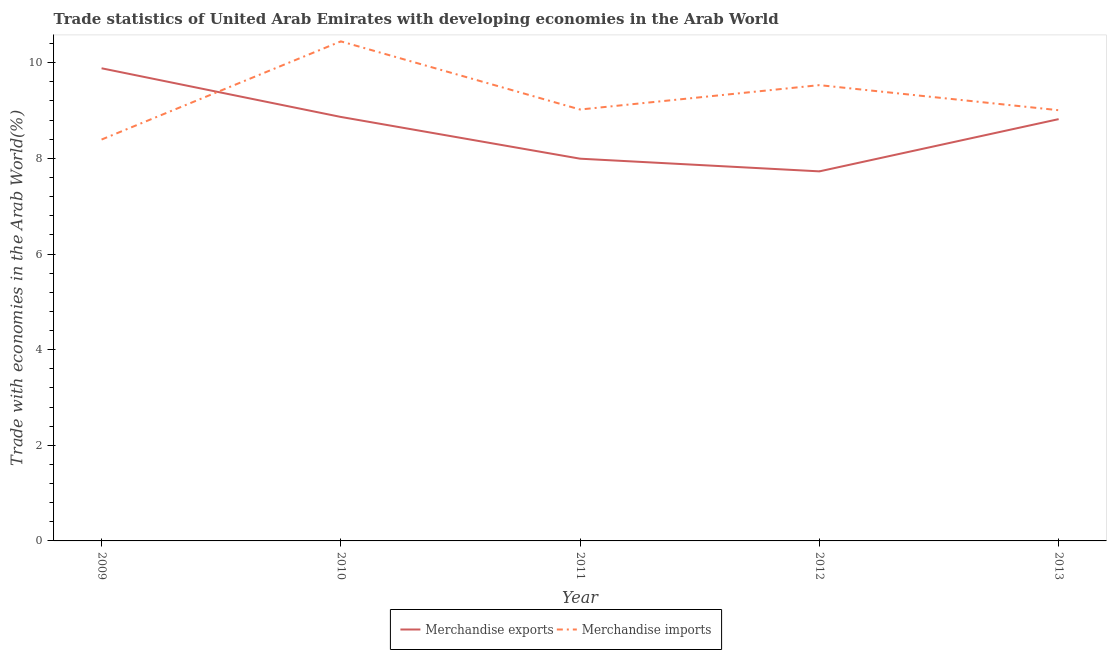Is the number of lines equal to the number of legend labels?
Offer a terse response. Yes. What is the merchandise exports in 2011?
Keep it short and to the point. 7.99. Across all years, what is the maximum merchandise exports?
Your response must be concise. 9.88. Across all years, what is the minimum merchandise exports?
Give a very brief answer. 7.73. What is the total merchandise exports in the graph?
Keep it short and to the point. 43.29. What is the difference between the merchandise imports in 2012 and that in 2013?
Ensure brevity in your answer.  0.52. What is the difference between the merchandise exports in 2010 and the merchandise imports in 2009?
Your response must be concise. 0.47. What is the average merchandise exports per year?
Offer a terse response. 8.66. In the year 2013, what is the difference between the merchandise imports and merchandise exports?
Offer a terse response. 0.19. In how many years, is the merchandise imports greater than 4 %?
Your answer should be very brief. 5. What is the ratio of the merchandise imports in 2010 to that in 2012?
Give a very brief answer. 1.1. What is the difference between the highest and the second highest merchandise exports?
Provide a succinct answer. 1.02. What is the difference between the highest and the lowest merchandise exports?
Give a very brief answer. 2.16. In how many years, is the merchandise exports greater than the average merchandise exports taken over all years?
Give a very brief answer. 3. Is the sum of the merchandise imports in 2010 and 2011 greater than the maximum merchandise exports across all years?
Your answer should be compact. Yes. Is the merchandise imports strictly less than the merchandise exports over the years?
Your answer should be compact. No. How many lines are there?
Give a very brief answer. 2. What is the difference between two consecutive major ticks on the Y-axis?
Provide a short and direct response. 2. Does the graph contain grids?
Offer a very short reply. No. Where does the legend appear in the graph?
Make the answer very short. Bottom center. What is the title of the graph?
Your response must be concise. Trade statistics of United Arab Emirates with developing economies in the Arab World. What is the label or title of the Y-axis?
Make the answer very short. Trade with economies in the Arab World(%). What is the Trade with economies in the Arab World(%) of Merchandise exports in 2009?
Give a very brief answer. 9.88. What is the Trade with economies in the Arab World(%) in Merchandise imports in 2009?
Ensure brevity in your answer.  8.39. What is the Trade with economies in the Arab World(%) of Merchandise exports in 2010?
Offer a terse response. 8.87. What is the Trade with economies in the Arab World(%) in Merchandise imports in 2010?
Offer a very short reply. 10.45. What is the Trade with economies in the Arab World(%) of Merchandise exports in 2011?
Offer a terse response. 7.99. What is the Trade with economies in the Arab World(%) of Merchandise imports in 2011?
Keep it short and to the point. 9.02. What is the Trade with economies in the Arab World(%) of Merchandise exports in 2012?
Your answer should be compact. 7.73. What is the Trade with economies in the Arab World(%) in Merchandise imports in 2012?
Your answer should be very brief. 9.53. What is the Trade with economies in the Arab World(%) in Merchandise exports in 2013?
Offer a very short reply. 8.82. What is the Trade with economies in the Arab World(%) in Merchandise imports in 2013?
Provide a short and direct response. 9.01. Across all years, what is the maximum Trade with economies in the Arab World(%) of Merchandise exports?
Your answer should be very brief. 9.88. Across all years, what is the maximum Trade with economies in the Arab World(%) in Merchandise imports?
Provide a short and direct response. 10.45. Across all years, what is the minimum Trade with economies in the Arab World(%) in Merchandise exports?
Give a very brief answer. 7.73. Across all years, what is the minimum Trade with economies in the Arab World(%) of Merchandise imports?
Offer a terse response. 8.39. What is the total Trade with economies in the Arab World(%) of Merchandise exports in the graph?
Your response must be concise. 43.29. What is the total Trade with economies in the Arab World(%) in Merchandise imports in the graph?
Ensure brevity in your answer.  46.4. What is the difference between the Trade with economies in the Arab World(%) in Merchandise exports in 2009 and that in 2010?
Offer a very short reply. 1.02. What is the difference between the Trade with economies in the Arab World(%) in Merchandise imports in 2009 and that in 2010?
Offer a terse response. -2.05. What is the difference between the Trade with economies in the Arab World(%) in Merchandise exports in 2009 and that in 2011?
Your response must be concise. 1.89. What is the difference between the Trade with economies in the Arab World(%) in Merchandise imports in 2009 and that in 2011?
Offer a very short reply. -0.63. What is the difference between the Trade with economies in the Arab World(%) of Merchandise exports in 2009 and that in 2012?
Give a very brief answer. 2.16. What is the difference between the Trade with economies in the Arab World(%) in Merchandise imports in 2009 and that in 2012?
Keep it short and to the point. -1.14. What is the difference between the Trade with economies in the Arab World(%) of Merchandise exports in 2009 and that in 2013?
Your answer should be very brief. 1.06. What is the difference between the Trade with economies in the Arab World(%) of Merchandise imports in 2009 and that in 2013?
Your response must be concise. -0.61. What is the difference between the Trade with economies in the Arab World(%) in Merchandise exports in 2010 and that in 2011?
Your answer should be very brief. 0.87. What is the difference between the Trade with economies in the Arab World(%) in Merchandise imports in 2010 and that in 2011?
Offer a terse response. 1.43. What is the difference between the Trade with economies in the Arab World(%) in Merchandise exports in 2010 and that in 2012?
Your answer should be very brief. 1.14. What is the difference between the Trade with economies in the Arab World(%) of Merchandise imports in 2010 and that in 2012?
Ensure brevity in your answer.  0.92. What is the difference between the Trade with economies in the Arab World(%) in Merchandise exports in 2010 and that in 2013?
Your answer should be very brief. 0.05. What is the difference between the Trade with economies in the Arab World(%) of Merchandise imports in 2010 and that in 2013?
Offer a very short reply. 1.44. What is the difference between the Trade with economies in the Arab World(%) of Merchandise exports in 2011 and that in 2012?
Give a very brief answer. 0.27. What is the difference between the Trade with economies in the Arab World(%) of Merchandise imports in 2011 and that in 2012?
Your response must be concise. -0.51. What is the difference between the Trade with economies in the Arab World(%) in Merchandise exports in 2011 and that in 2013?
Offer a terse response. -0.83. What is the difference between the Trade with economies in the Arab World(%) in Merchandise imports in 2011 and that in 2013?
Your answer should be compact. 0.01. What is the difference between the Trade with economies in the Arab World(%) of Merchandise exports in 2012 and that in 2013?
Your answer should be compact. -1.09. What is the difference between the Trade with economies in the Arab World(%) in Merchandise imports in 2012 and that in 2013?
Provide a succinct answer. 0.52. What is the difference between the Trade with economies in the Arab World(%) in Merchandise exports in 2009 and the Trade with economies in the Arab World(%) in Merchandise imports in 2010?
Provide a short and direct response. -0.56. What is the difference between the Trade with economies in the Arab World(%) in Merchandise exports in 2009 and the Trade with economies in the Arab World(%) in Merchandise imports in 2011?
Provide a short and direct response. 0.86. What is the difference between the Trade with economies in the Arab World(%) in Merchandise exports in 2009 and the Trade with economies in the Arab World(%) in Merchandise imports in 2012?
Ensure brevity in your answer.  0.35. What is the difference between the Trade with economies in the Arab World(%) of Merchandise exports in 2009 and the Trade with economies in the Arab World(%) of Merchandise imports in 2013?
Your response must be concise. 0.88. What is the difference between the Trade with economies in the Arab World(%) in Merchandise exports in 2010 and the Trade with economies in the Arab World(%) in Merchandise imports in 2011?
Provide a short and direct response. -0.16. What is the difference between the Trade with economies in the Arab World(%) of Merchandise exports in 2010 and the Trade with economies in the Arab World(%) of Merchandise imports in 2012?
Ensure brevity in your answer.  -0.67. What is the difference between the Trade with economies in the Arab World(%) in Merchandise exports in 2010 and the Trade with economies in the Arab World(%) in Merchandise imports in 2013?
Your answer should be very brief. -0.14. What is the difference between the Trade with economies in the Arab World(%) of Merchandise exports in 2011 and the Trade with economies in the Arab World(%) of Merchandise imports in 2012?
Give a very brief answer. -1.54. What is the difference between the Trade with economies in the Arab World(%) of Merchandise exports in 2011 and the Trade with economies in the Arab World(%) of Merchandise imports in 2013?
Provide a short and direct response. -1.01. What is the difference between the Trade with economies in the Arab World(%) in Merchandise exports in 2012 and the Trade with economies in the Arab World(%) in Merchandise imports in 2013?
Your answer should be very brief. -1.28. What is the average Trade with economies in the Arab World(%) of Merchandise exports per year?
Offer a very short reply. 8.66. What is the average Trade with economies in the Arab World(%) of Merchandise imports per year?
Offer a terse response. 9.28. In the year 2009, what is the difference between the Trade with economies in the Arab World(%) in Merchandise exports and Trade with economies in the Arab World(%) in Merchandise imports?
Your response must be concise. 1.49. In the year 2010, what is the difference between the Trade with economies in the Arab World(%) in Merchandise exports and Trade with economies in the Arab World(%) in Merchandise imports?
Your answer should be very brief. -1.58. In the year 2011, what is the difference between the Trade with economies in the Arab World(%) in Merchandise exports and Trade with economies in the Arab World(%) in Merchandise imports?
Provide a short and direct response. -1.03. In the year 2012, what is the difference between the Trade with economies in the Arab World(%) in Merchandise exports and Trade with economies in the Arab World(%) in Merchandise imports?
Your answer should be compact. -1.8. In the year 2013, what is the difference between the Trade with economies in the Arab World(%) of Merchandise exports and Trade with economies in the Arab World(%) of Merchandise imports?
Offer a terse response. -0.19. What is the ratio of the Trade with economies in the Arab World(%) of Merchandise exports in 2009 to that in 2010?
Make the answer very short. 1.11. What is the ratio of the Trade with economies in the Arab World(%) in Merchandise imports in 2009 to that in 2010?
Your answer should be very brief. 0.8. What is the ratio of the Trade with economies in the Arab World(%) in Merchandise exports in 2009 to that in 2011?
Your response must be concise. 1.24. What is the ratio of the Trade with economies in the Arab World(%) of Merchandise imports in 2009 to that in 2011?
Offer a very short reply. 0.93. What is the ratio of the Trade with economies in the Arab World(%) of Merchandise exports in 2009 to that in 2012?
Offer a terse response. 1.28. What is the ratio of the Trade with economies in the Arab World(%) in Merchandise imports in 2009 to that in 2012?
Provide a succinct answer. 0.88. What is the ratio of the Trade with economies in the Arab World(%) in Merchandise exports in 2009 to that in 2013?
Offer a terse response. 1.12. What is the ratio of the Trade with economies in the Arab World(%) in Merchandise imports in 2009 to that in 2013?
Make the answer very short. 0.93. What is the ratio of the Trade with economies in the Arab World(%) in Merchandise exports in 2010 to that in 2011?
Offer a very short reply. 1.11. What is the ratio of the Trade with economies in the Arab World(%) in Merchandise imports in 2010 to that in 2011?
Your answer should be compact. 1.16. What is the ratio of the Trade with economies in the Arab World(%) in Merchandise exports in 2010 to that in 2012?
Provide a short and direct response. 1.15. What is the ratio of the Trade with economies in the Arab World(%) in Merchandise imports in 2010 to that in 2012?
Your answer should be very brief. 1.1. What is the ratio of the Trade with economies in the Arab World(%) of Merchandise imports in 2010 to that in 2013?
Make the answer very short. 1.16. What is the ratio of the Trade with economies in the Arab World(%) of Merchandise exports in 2011 to that in 2012?
Your answer should be very brief. 1.03. What is the ratio of the Trade with economies in the Arab World(%) of Merchandise imports in 2011 to that in 2012?
Provide a succinct answer. 0.95. What is the ratio of the Trade with economies in the Arab World(%) of Merchandise exports in 2011 to that in 2013?
Provide a succinct answer. 0.91. What is the ratio of the Trade with economies in the Arab World(%) in Merchandise exports in 2012 to that in 2013?
Make the answer very short. 0.88. What is the ratio of the Trade with economies in the Arab World(%) of Merchandise imports in 2012 to that in 2013?
Offer a terse response. 1.06. What is the difference between the highest and the second highest Trade with economies in the Arab World(%) in Merchandise exports?
Make the answer very short. 1.02. What is the difference between the highest and the second highest Trade with economies in the Arab World(%) in Merchandise imports?
Keep it short and to the point. 0.92. What is the difference between the highest and the lowest Trade with economies in the Arab World(%) in Merchandise exports?
Ensure brevity in your answer.  2.16. What is the difference between the highest and the lowest Trade with economies in the Arab World(%) in Merchandise imports?
Give a very brief answer. 2.05. 